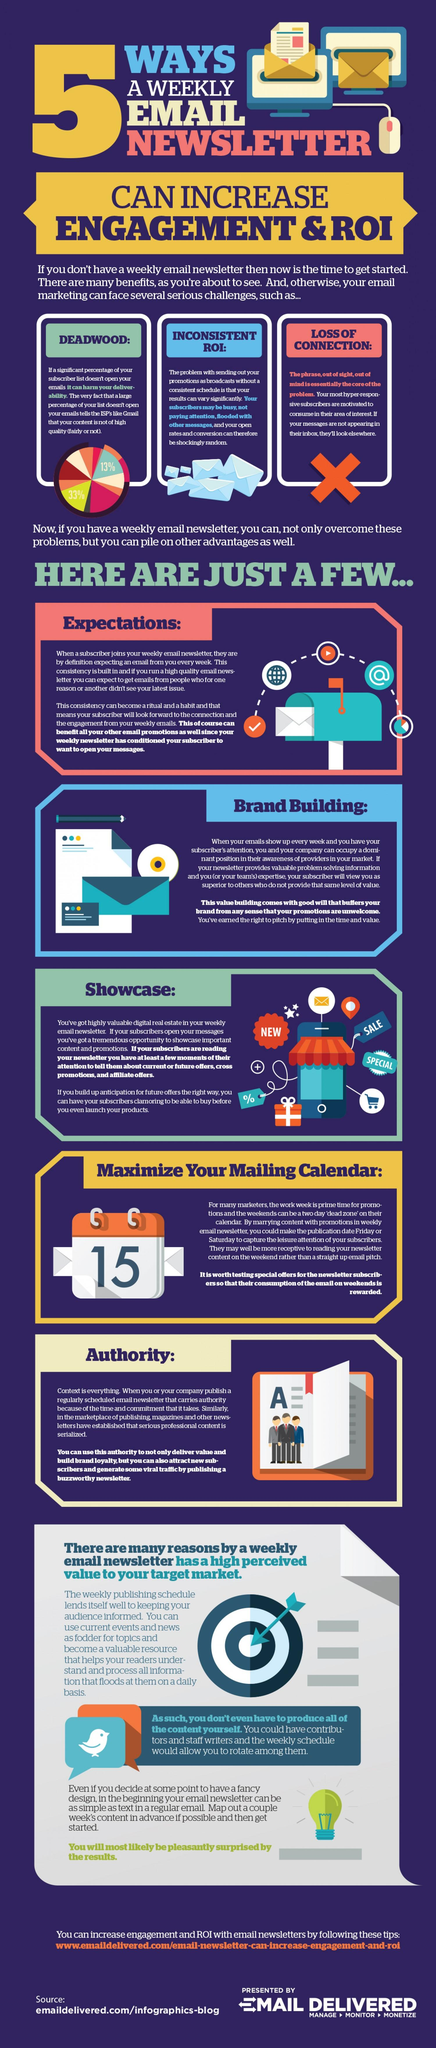Specify some key components in this picture. Weekly email newsletters have the advantages of increasing expectations, building brand image, and showcasing products or services. In this sentence, "here" refers to the article or source being discussed. The word "mentioned" means "to bring up or mention" and "5" is a list of five advantages of weekly email newsletters. So, the sentence can be translated to "What are the five advantages of weekly email newsletters that have been mentioned in this article? The three main challenges faced by email marketing are declining engagement, inconsistent return on investment, and loss of connection with customers. We have the potential to enlist the aid of contributors and staff writers to produce content for our weekly email newsletters. The image on the calendar shows the date 15.. 